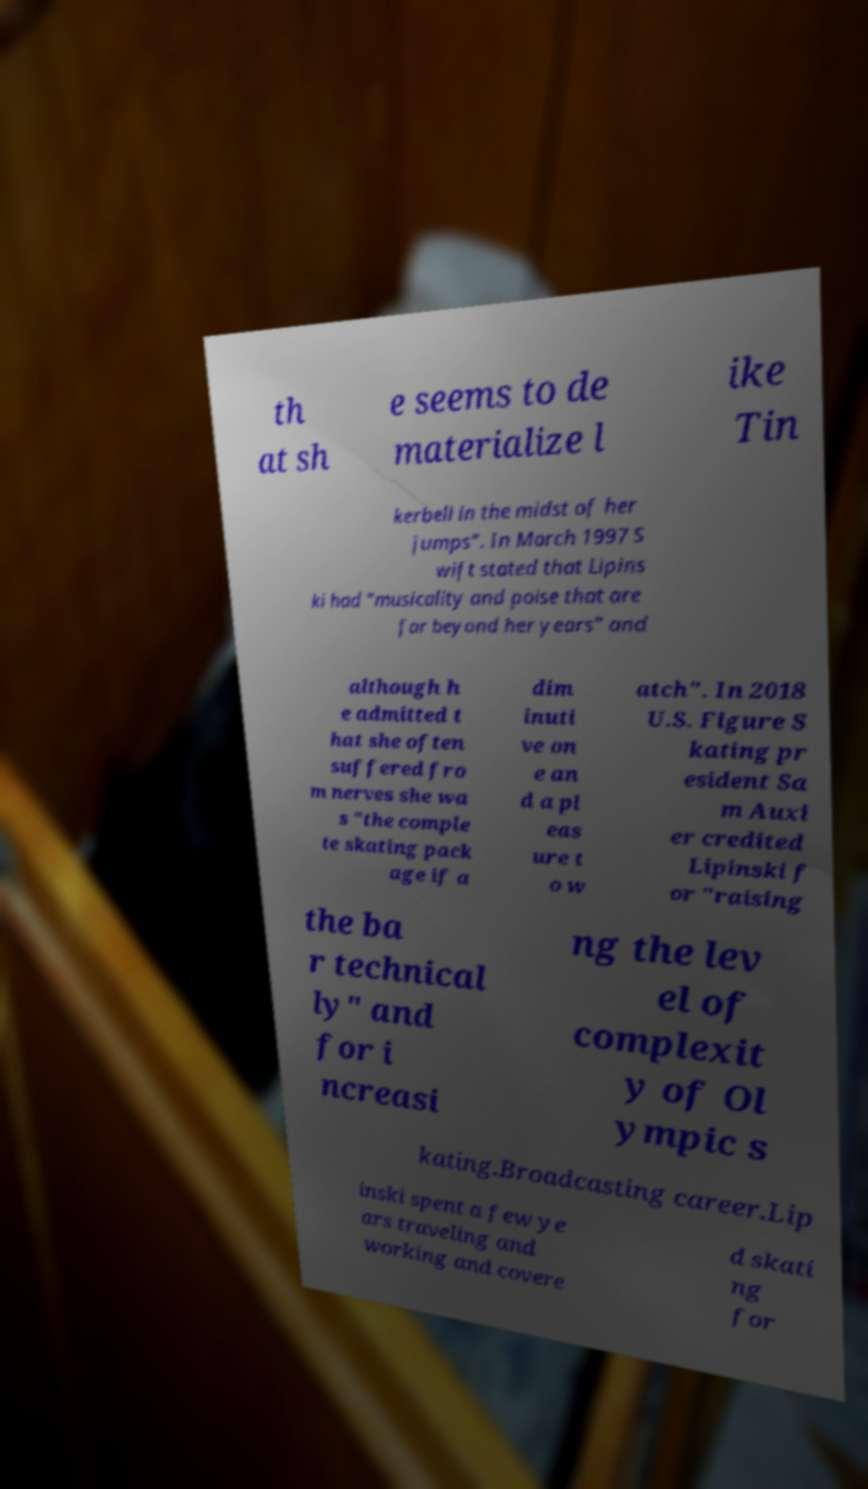I need the written content from this picture converted into text. Can you do that? th at sh e seems to de materialize l ike Tin kerbell in the midst of her jumps". In March 1997 S wift stated that Lipins ki had "musicality and poise that are far beyond her years" and although h e admitted t hat she often suffered fro m nerves she wa s "the comple te skating pack age if a dim inuti ve on e an d a pl eas ure t o w atch". In 2018 U.S. Figure S kating pr esident Sa m Auxi er credited Lipinski f or "raising the ba r technical ly" and for i ncreasi ng the lev el of complexit y of Ol ympic s kating.Broadcasting career.Lip inski spent a few ye ars traveling and working and covere d skati ng for 